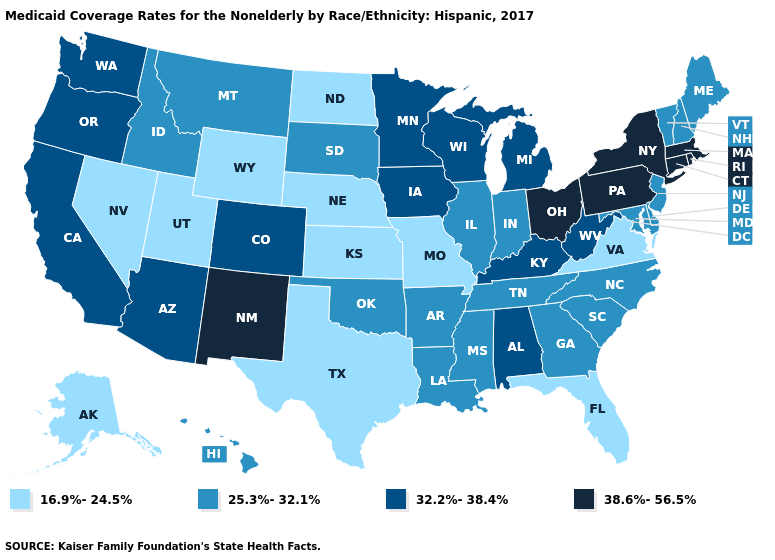Name the states that have a value in the range 16.9%-24.5%?
Write a very short answer. Alaska, Florida, Kansas, Missouri, Nebraska, Nevada, North Dakota, Texas, Utah, Virginia, Wyoming. Among the states that border Delaware , does New Jersey have the highest value?
Write a very short answer. No. Name the states that have a value in the range 16.9%-24.5%?
Keep it brief. Alaska, Florida, Kansas, Missouri, Nebraska, Nevada, North Dakota, Texas, Utah, Virginia, Wyoming. Name the states that have a value in the range 16.9%-24.5%?
Answer briefly. Alaska, Florida, Kansas, Missouri, Nebraska, Nevada, North Dakota, Texas, Utah, Virginia, Wyoming. Does the first symbol in the legend represent the smallest category?
Give a very brief answer. Yes. Does Arkansas have a higher value than Maryland?
Keep it brief. No. Which states have the highest value in the USA?
Be succinct. Connecticut, Massachusetts, New Mexico, New York, Ohio, Pennsylvania, Rhode Island. Among the states that border Massachusetts , does Rhode Island have the lowest value?
Answer briefly. No. Which states hav the highest value in the South?
Quick response, please. Alabama, Kentucky, West Virginia. Does Mississippi have the same value as Virginia?
Quick response, please. No. What is the lowest value in the USA?
Write a very short answer. 16.9%-24.5%. What is the value of Colorado?
Be succinct. 32.2%-38.4%. Name the states that have a value in the range 38.6%-56.5%?
Quick response, please. Connecticut, Massachusetts, New Mexico, New York, Ohio, Pennsylvania, Rhode Island. Among the states that border Oklahoma , which have the lowest value?
Give a very brief answer. Kansas, Missouri, Texas. 